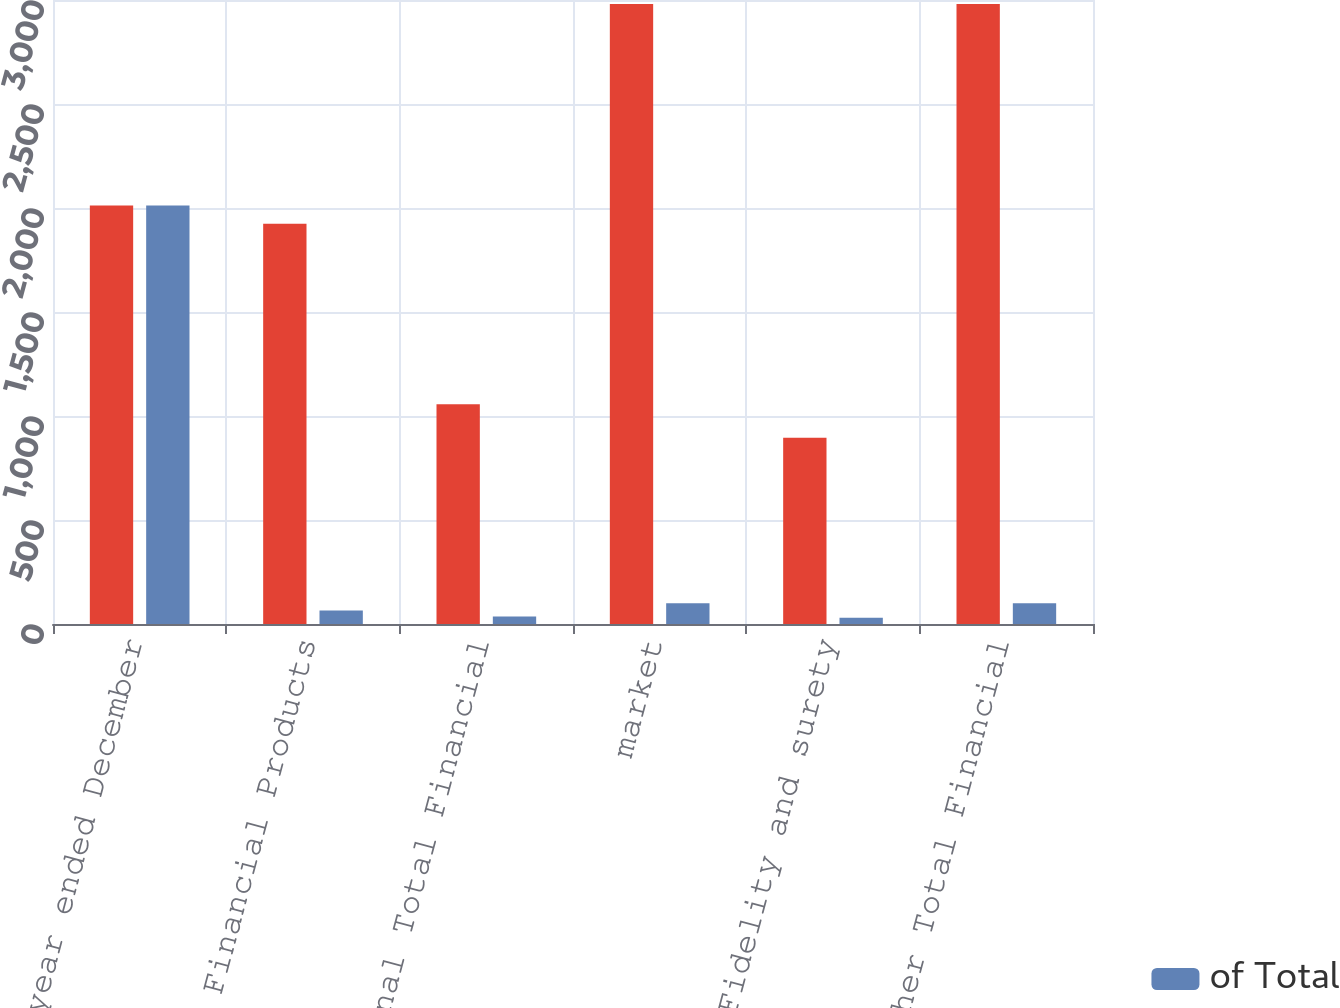Convert chart to OTSL. <chart><loc_0><loc_0><loc_500><loc_500><stacked_bar_chart><ecel><fcel>(for the year ended December<fcel>Bond & Financial Products<fcel>International Total Financial<fcel>market<fcel>Fidelity and surety<fcel>Other Total Financial<nl><fcel>nan<fcel>2012<fcel>1924<fcel>1057<fcel>2981<fcel>895<fcel>2981<nl><fcel>of Total<fcel>2012<fcel>64.5<fcel>35.5<fcel>100<fcel>30<fcel>100<nl></chart> 